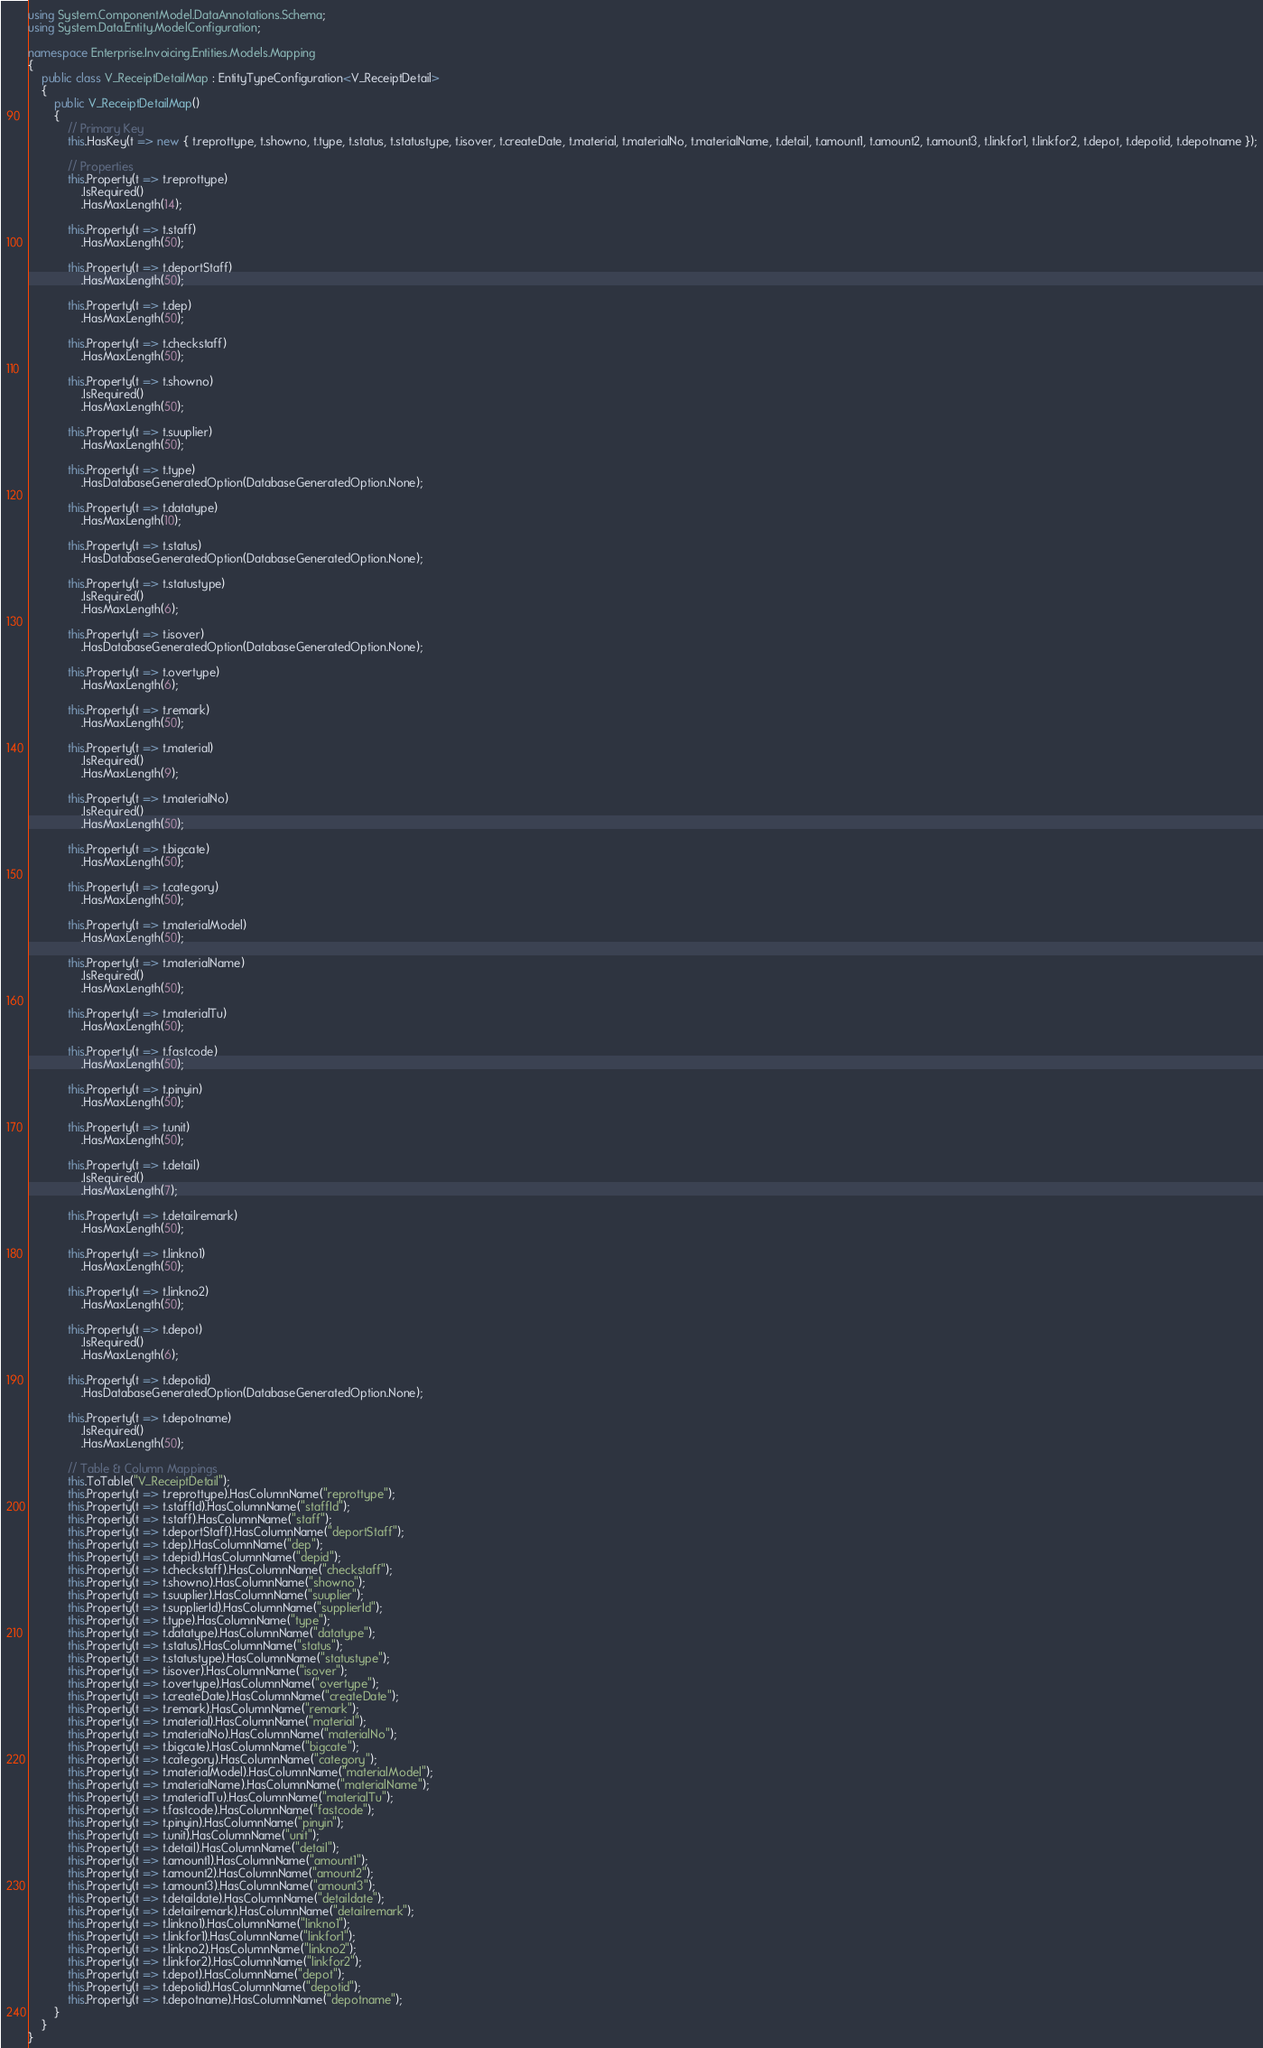<code> <loc_0><loc_0><loc_500><loc_500><_C#_>using System.ComponentModel.DataAnnotations.Schema;
using System.Data.Entity.ModelConfiguration;

namespace Enterprise.Invoicing.Entities.Models.Mapping
{
    public class V_ReceiptDetailMap : EntityTypeConfiguration<V_ReceiptDetail>
    {
        public V_ReceiptDetailMap()
        {
            // Primary Key
            this.HasKey(t => new { t.reprottype, t.showno, t.type, t.status, t.statustype, t.isover, t.createDate, t.material, t.materialNo, t.materialName, t.detail, t.amount1, t.amount2, t.amount3, t.linkfor1, t.linkfor2, t.depot, t.depotid, t.depotname });

            // Properties
            this.Property(t => t.reprottype)
                .IsRequired()
                .HasMaxLength(14);

            this.Property(t => t.staff)
                .HasMaxLength(50);

            this.Property(t => t.deportStaff)
                .HasMaxLength(50);

            this.Property(t => t.dep)
                .HasMaxLength(50);

            this.Property(t => t.checkstaff)
                .HasMaxLength(50);

            this.Property(t => t.showno)
                .IsRequired()
                .HasMaxLength(50);

            this.Property(t => t.suuplier)
                .HasMaxLength(50);

            this.Property(t => t.type)
                .HasDatabaseGeneratedOption(DatabaseGeneratedOption.None);

            this.Property(t => t.datatype)
                .HasMaxLength(10);

            this.Property(t => t.status)
                .HasDatabaseGeneratedOption(DatabaseGeneratedOption.None);

            this.Property(t => t.statustype)
                .IsRequired()
                .HasMaxLength(6);

            this.Property(t => t.isover)
                .HasDatabaseGeneratedOption(DatabaseGeneratedOption.None);

            this.Property(t => t.overtype)
                .HasMaxLength(6);

            this.Property(t => t.remark)
                .HasMaxLength(50);

            this.Property(t => t.material)
                .IsRequired()
                .HasMaxLength(9);

            this.Property(t => t.materialNo)
                .IsRequired()
                .HasMaxLength(50);

            this.Property(t => t.bigcate)
                .HasMaxLength(50);

            this.Property(t => t.category)
                .HasMaxLength(50);

            this.Property(t => t.materialModel)
                .HasMaxLength(50);

            this.Property(t => t.materialName)
                .IsRequired()
                .HasMaxLength(50);

            this.Property(t => t.materialTu)
                .HasMaxLength(50);

            this.Property(t => t.fastcode)
                .HasMaxLength(50);

            this.Property(t => t.pinyin)
                .HasMaxLength(50);

            this.Property(t => t.unit)
                .HasMaxLength(50);

            this.Property(t => t.detail)
                .IsRequired()
                .HasMaxLength(7);

            this.Property(t => t.detailremark)
                .HasMaxLength(50);

            this.Property(t => t.linkno1)
                .HasMaxLength(50);

            this.Property(t => t.linkno2)
                .HasMaxLength(50);

            this.Property(t => t.depot)
                .IsRequired()
                .HasMaxLength(6);

            this.Property(t => t.depotid)
                .HasDatabaseGeneratedOption(DatabaseGeneratedOption.None);

            this.Property(t => t.depotname)
                .IsRequired()
                .HasMaxLength(50);

            // Table & Column Mappings
            this.ToTable("V_ReceiptDetail");
            this.Property(t => t.reprottype).HasColumnName("reprottype");
            this.Property(t => t.staffId).HasColumnName("staffId");
            this.Property(t => t.staff).HasColumnName("staff");
            this.Property(t => t.deportStaff).HasColumnName("deportStaff");
            this.Property(t => t.dep).HasColumnName("dep");
            this.Property(t => t.depid).HasColumnName("depid");
            this.Property(t => t.checkstaff).HasColumnName("checkstaff");
            this.Property(t => t.showno).HasColumnName("showno");
            this.Property(t => t.suuplier).HasColumnName("suuplier");
            this.Property(t => t.supplierId).HasColumnName("supplierId");
            this.Property(t => t.type).HasColumnName("type");
            this.Property(t => t.datatype).HasColumnName("datatype");
            this.Property(t => t.status).HasColumnName("status");
            this.Property(t => t.statustype).HasColumnName("statustype");
            this.Property(t => t.isover).HasColumnName("isover");
            this.Property(t => t.overtype).HasColumnName("overtype");
            this.Property(t => t.createDate).HasColumnName("createDate");
            this.Property(t => t.remark).HasColumnName("remark");
            this.Property(t => t.material).HasColumnName("material");
            this.Property(t => t.materialNo).HasColumnName("materialNo");
            this.Property(t => t.bigcate).HasColumnName("bigcate");
            this.Property(t => t.category).HasColumnName("category");
            this.Property(t => t.materialModel).HasColumnName("materialModel");
            this.Property(t => t.materialName).HasColumnName("materialName");
            this.Property(t => t.materialTu).HasColumnName("materialTu");
            this.Property(t => t.fastcode).HasColumnName("fastcode");
            this.Property(t => t.pinyin).HasColumnName("pinyin");
            this.Property(t => t.unit).HasColumnName("unit");
            this.Property(t => t.detail).HasColumnName("detail");
            this.Property(t => t.amount1).HasColumnName("amount1");
            this.Property(t => t.amount2).HasColumnName("amount2");
            this.Property(t => t.amount3).HasColumnName("amount3");
            this.Property(t => t.detaildate).HasColumnName("detaildate");
            this.Property(t => t.detailremark).HasColumnName("detailremark");
            this.Property(t => t.linkno1).HasColumnName("linkno1");
            this.Property(t => t.linkfor1).HasColumnName("linkfor1");
            this.Property(t => t.linkno2).HasColumnName("linkno2");
            this.Property(t => t.linkfor2).HasColumnName("linkfor2");
            this.Property(t => t.depot).HasColumnName("depot");
            this.Property(t => t.depotid).HasColumnName("depotid");
            this.Property(t => t.depotname).HasColumnName("depotname");
        }
    }
}
</code> 